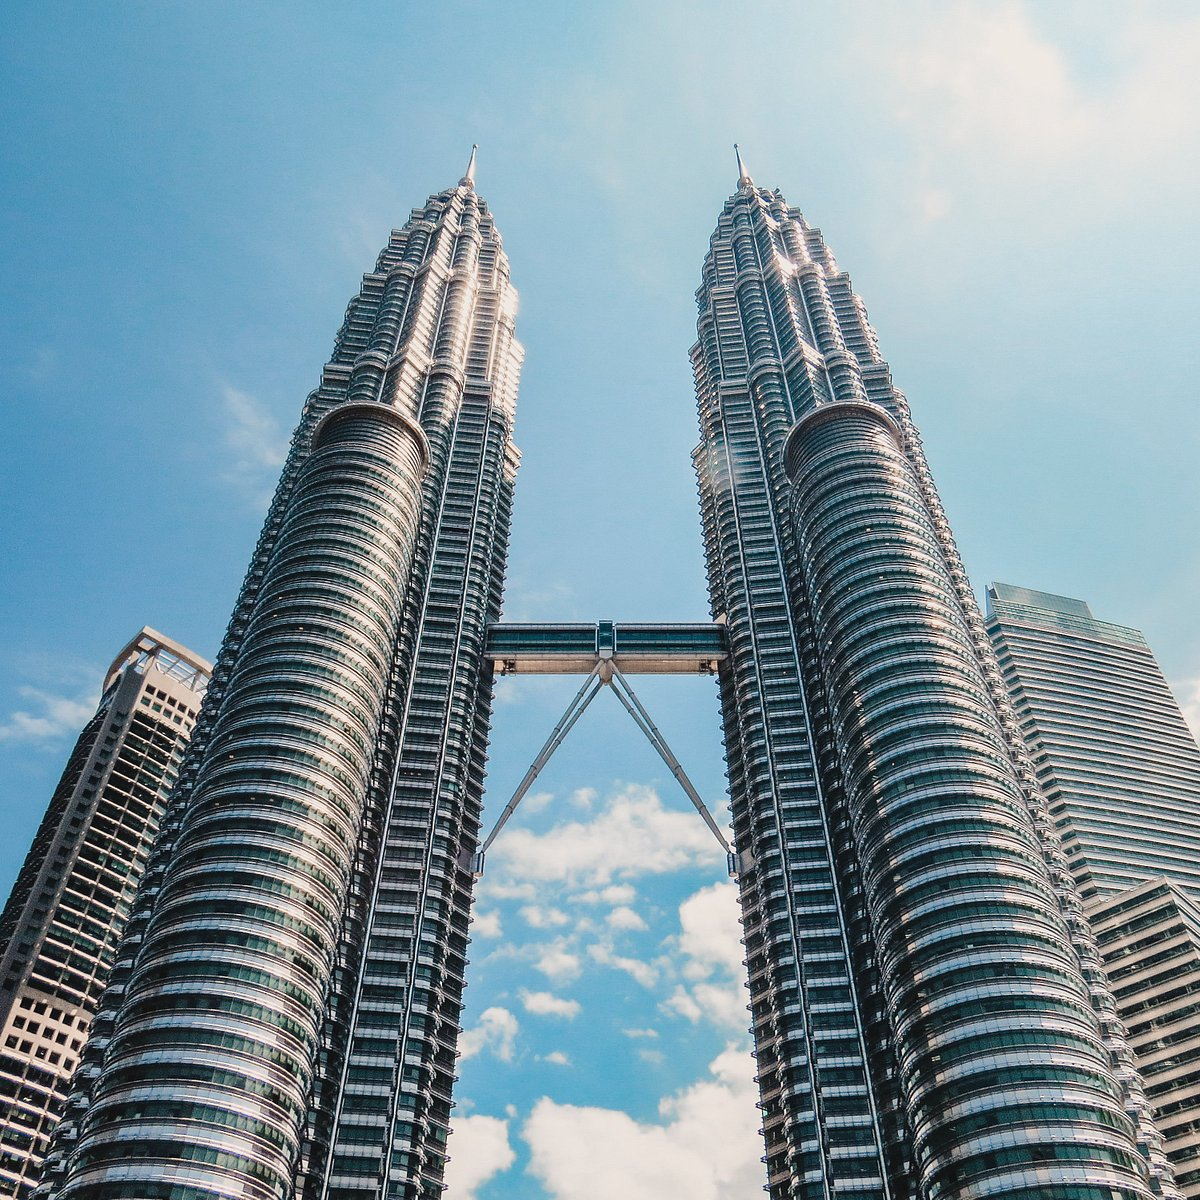How do the Petronas Twin Towers influence the skyline and culture of Kuala Lumpur? The Petronas Twin Towers dramatically transform the skyline of Kuala Lumpur, serving as a beacon of Malaysia's rapid economic development and its aspirations in the global arena. These towers are not just office buildings; they are a cultural hub, featuring a concert hall, a shopping mall, and several multinational corporations, thereby making a significant impact on the local culture by promoting arts, commerce, and international connectivity. Their iconic status also attracts tourists from around the globe, contributing to Kuala Lumpur's identity as a cosmopolitan city rich in diverse cultural offerings. 